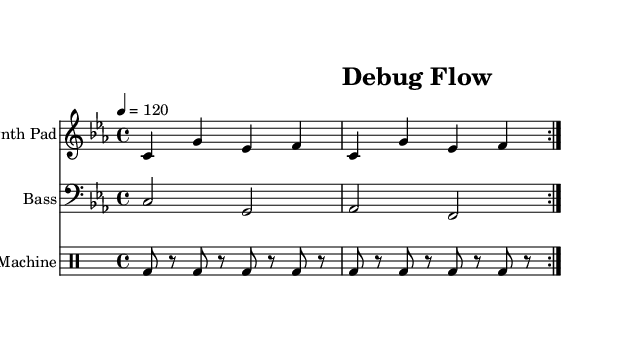What is the key signature of this music? The key signature is C minor, indicated by the presence of three flats (B flat, E flat, and A flat) in the key signature area.
Answer: C minor What is the time signature of this music? The time signature is found at the beginning of the piece, showing 4/4, meaning there are four beats in a measure.
Answer: 4/4 What is the tempo marking of this music? The tempo marking indicates the speed of the piece, which is written as “4 = 120,” meaning there are 120 beats per minute.
Answer: 120 How many measures are repeated in the synth pad section? The synth pad section has a volta, which indicates a repeat of the same section twice, so there are two measures repeated.
Answer: 2 What instrument is the drum machine in this score? The drum machine is notated in the staff labeled "Drum Machine," indicating it is specifically set up for drum sounds and patterns.
Answer: Drum Machine How does the bass line move in relation to the synth pad line? The bass line provides a foundational support for the synth pad, alternating between the root note C and the relative notes G and A flat, creating a harmonic structure typical of ambient house music.
Answer: Alternates roots 